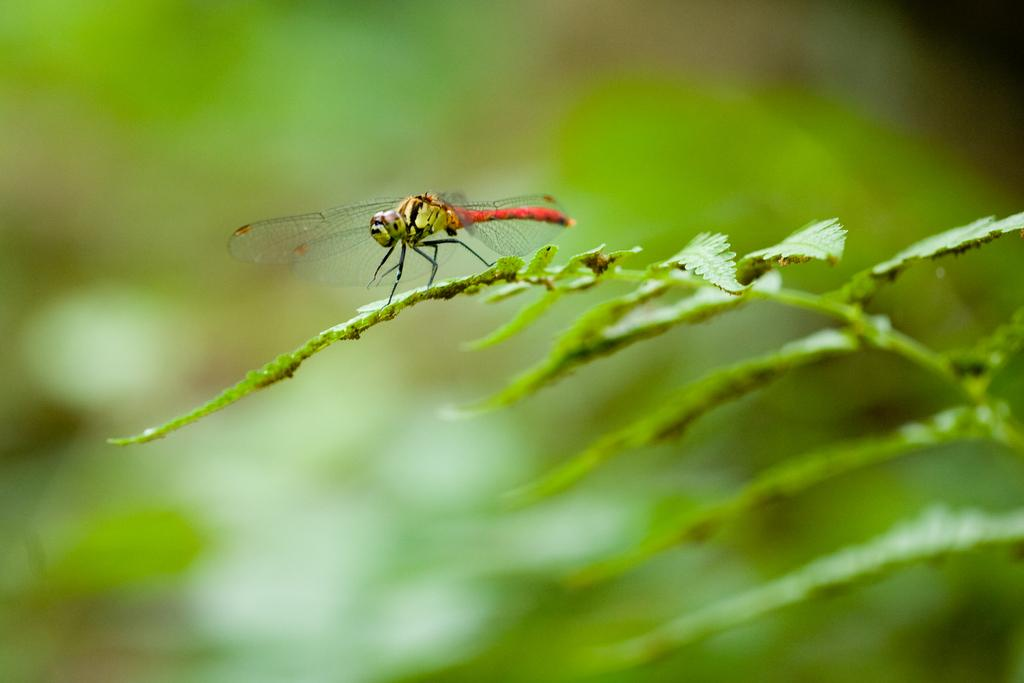What insect is present in the image? There is a dragonfly in the image. Where is the dragonfly located? The dragonfly is on leaves. Can you describe the background of the image? The background of the image is blurred. What type of horses are used to cover the leaves in the image? There are no horses present in the image, and leaves are not covered by any animals. 